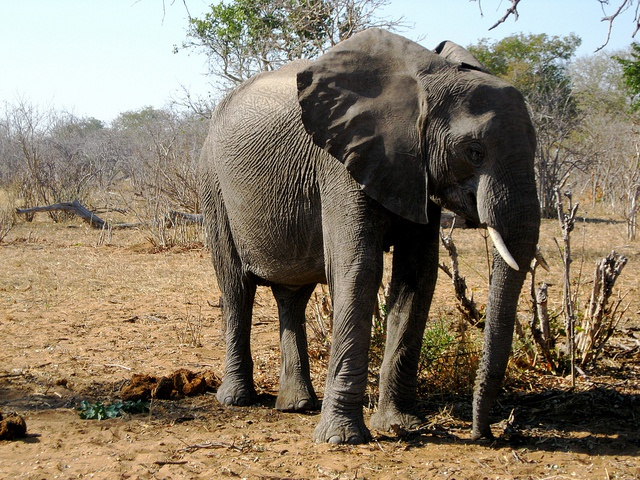Describe the objects in this image and their specific colors. I can see a elephant in white, black, gray, darkgray, and tan tones in this image. 